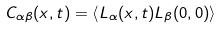<formula> <loc_0><loc_0><loc_500><loc_500>C _ { \alpha \beta } ( x , t ) = \left \langle L _ { \alpha } ( x , t ) L _ { \beta } ( 0 , 0 ) \right \rangle</formula> 